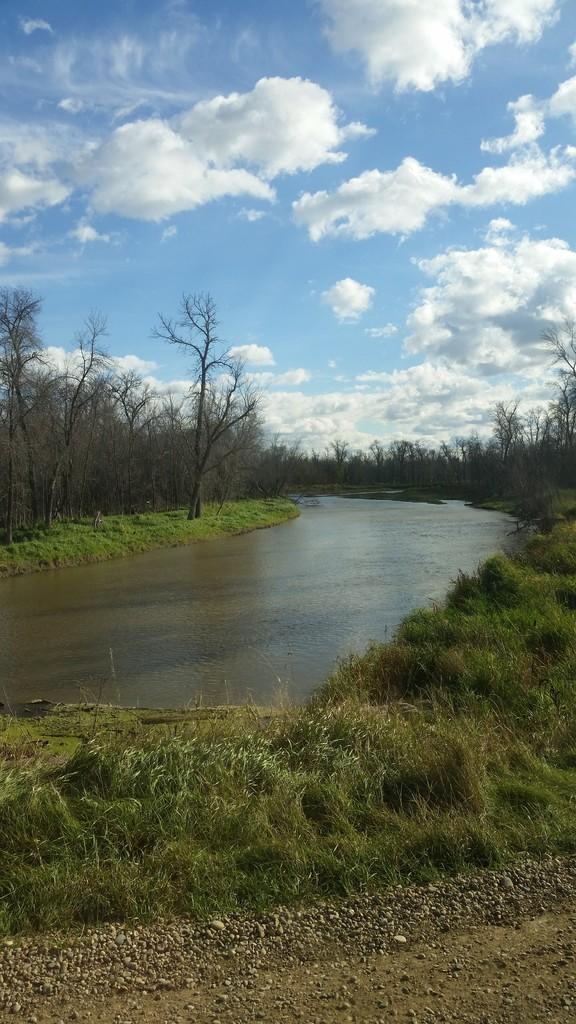What type of vegetation can be seen in the image? There are trees in the image. What is the color of the grass in the image? There is green grass in the image. What natural element is visible in the image besides trees and grass? There is water visible in the image. What type of material is present in the image? There are stones in the image. What is the color of the sky in the image? The sky is blue and white in color. What type of curtain is hanging in the image? There is no curtain present in the image. What shape is the water taking in the image? The water is not taking a specific shape in the image; it is simply visible. 